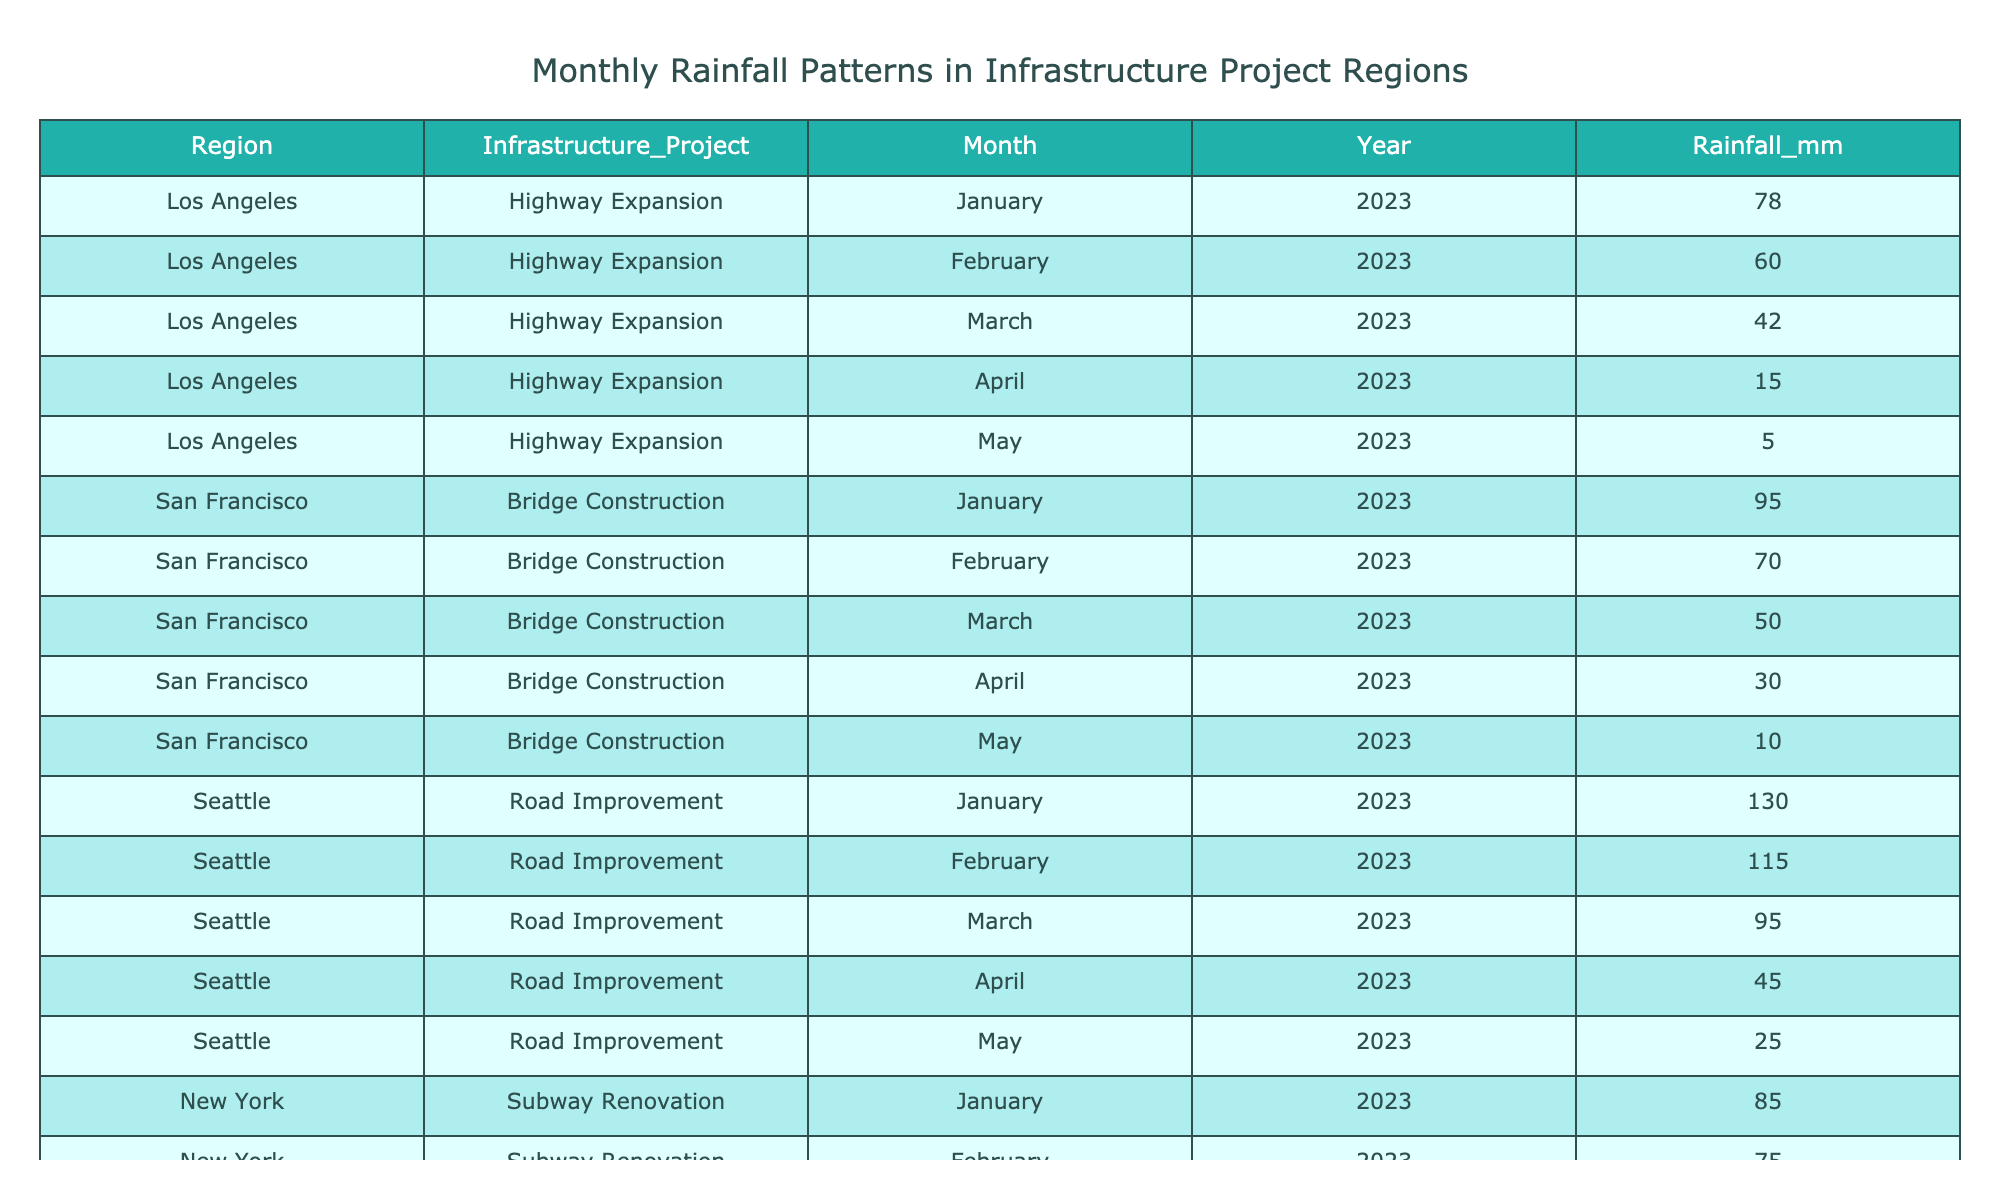What was the rainfall in Seattle during March 2023? Referring to the table, the entry for Seattle in March 2023 shows a rainfall value of 95.0 mm.
Answer: 95.0 mm Which region experienced the highest total rainfall from January to May 2023? To find the region with the highest total rainfall, sum the rainfall values for each region: Los Angeles (78 + 60 + 42 + 15 + 5 = 200), San Francisco (95 + 70 + 50 + 30 + 10 = 255), Seattle (130 + 115 + 95 + 45 + 25 = 410), New York (85 + 75 + 55 + 20 + 12 = 247), Austin (70 + 59 + 39 + 13 + 7 = 188). Seattle has the highest total at 410 mm.
Answer: Seattle Did New York receive more rainfall than Austin in February 2023? The rainfall values are compared: New York had 75.0 mm and Austin had 59.0 mm in February 2023. Since 75.0 is greater than 59.0, New York received more rainfall.
Answer: Yes What is the average rainfall in Los Angeles from January to May 2023? To calculate the average, sum the Los Angeles rainfall amounts (78 + 60 + 42 + 15 + 5 = 200) and divide by the number of months (5). The average is 200 / 5 = 40.0 mm.
Answer: 40.0 mm What was the total rainfall in regions with infrastructure projects for April 2023? Sum the rainfall values for all regions in April: Los Angeles (15 mm) + San Francisco (30 mm) + Seattle (45 mm) + New York (20 mm) + Austin (13 mm) = 15 + 30 + 45 + 20 + 13 = 133 mm.
Answer: 133 mm Which two months showed the largest decrease in rainfall for San Francisco? For San Francisco, the values for February and March are compared (February: 70 mm, March: 50 mm). The decrease is 70 - 50 = 20 mm. Then compare March and April (March: 50 mm, April: 30 mm) with a decrease of 50 - 30 = 20 mm. Both have the same decrease of 20 mm.
Answer: February and March How did the rainfall in Seattle change from January to May 2023? To analyze the change, compare the rainfall values month-to-month: The rainfall decreased from 130 (January) to 115 (February, -15), 95 (March, -20), 45 (April, -50), and 25 (May, -20). This shows a consistent decrease overall, with a final drop of 105 mm.
Answer: Decreased consistently Did any region have less than 10 mm of rainfall in May 2023? Check the May rainfall values for all regions. Los Angeles (5 mm), San Francisco (10 mm), Seattle (25 mm), New York (12 mm), and Austin (7 mm) show that Los Angeles and Austin had less than 10 mm.
Answer: Yes 